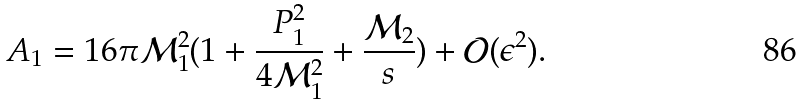<formula> <loc_0><loc_0><loc_500><loc_500>A _ { 1 } = 1 6 \pi { \mathcal { M } } _ { 1 } ^ { 2 } ( 1 + \frac { P _ { 1 } ^ { 2 } } { 4 { \mathcal { M } } _ { 1 } ^ { 2 } } + \frac { { \mathcal { M } } _ { 2 } } { s } ) + { \mathcal { O } } ( \epsilon ^ { 2 } ) .</formula> 